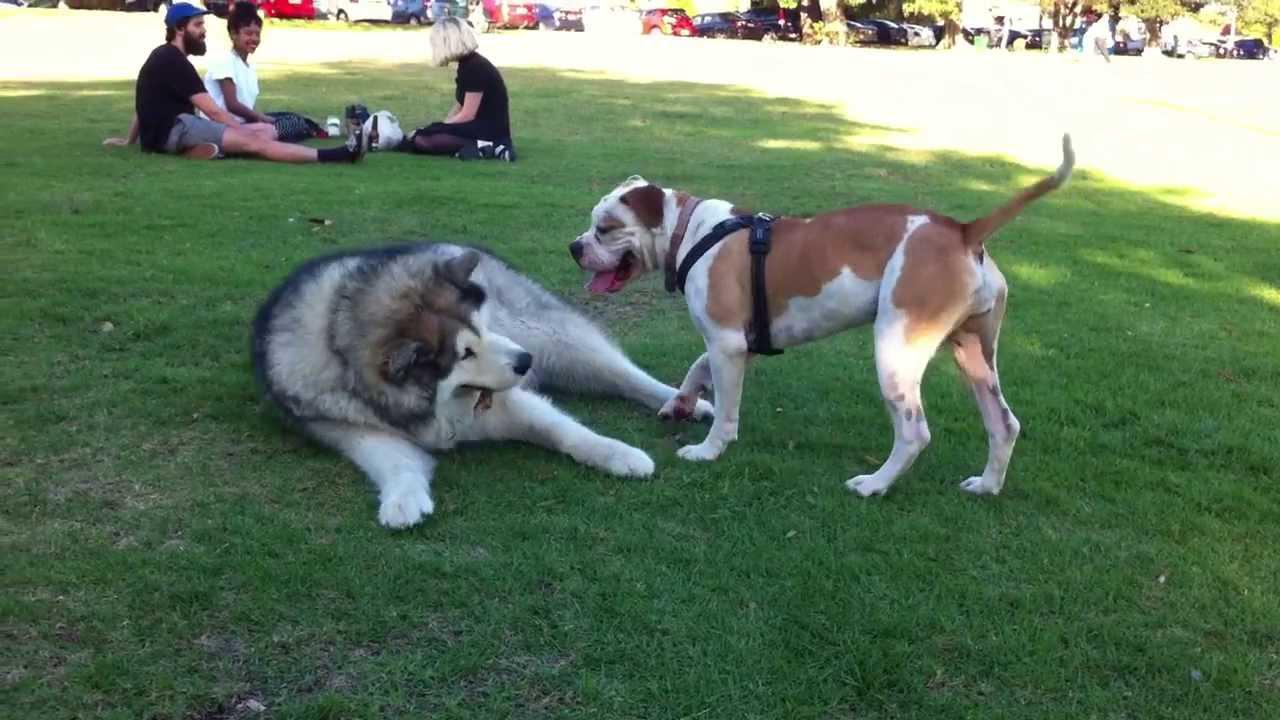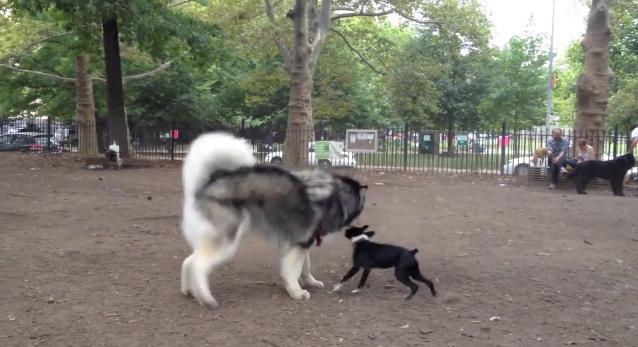The first image is the image on the left, the second image is the image on the right. Given the left and right images, does the statement "Each image shows two dogs interacting outdoors, and one image contains two gray-and-white husky dogs." hold true? Answer yes or no. No. The first image is the image on the left, the second image is the image on the right. Assess this claim about the two images: "Two dogs are standing in the grass in the image on the left.". Correct or not? Answer yes or no. No. 